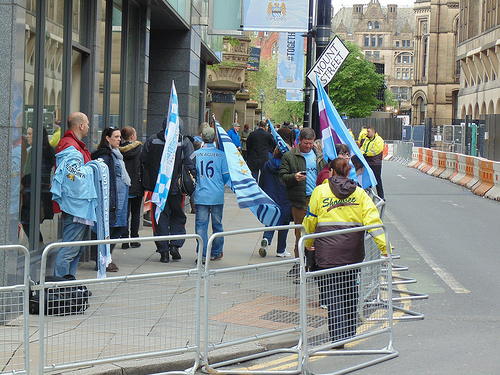<image>
Is there a flag next to the bag? No. The flag is not positioned next to the bag. They are located in different areas of the scene. 